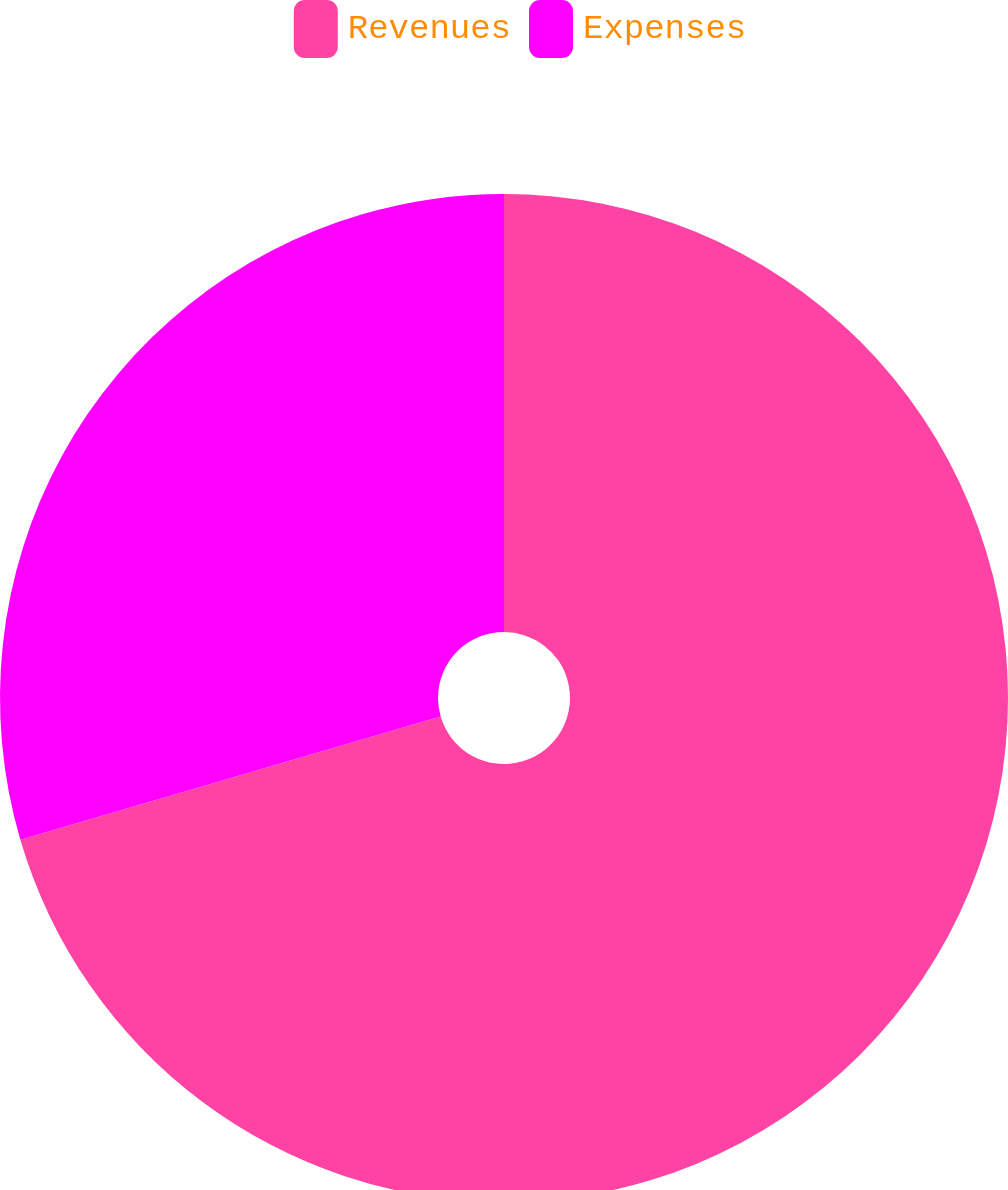Convert chart. <chart><loc_0><loc_0><loc_500><loc_500><pie_chart><fcel>Revenues<fcel>Expenses<nl><fcel>70.46%<fcel>29.54%<nl></chart> 